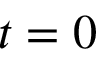<formula> <loc_0><loc_0><loc_500><loc_500>t = 0</formula> 